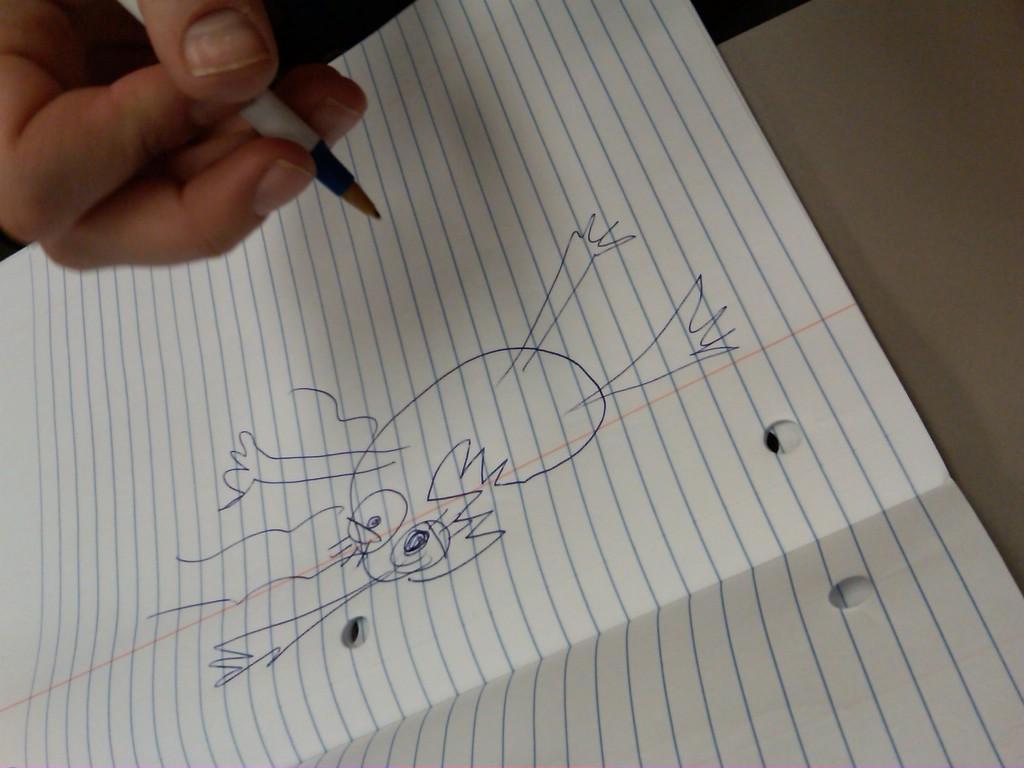Please provide a concise description of this image. In this image we can see some person holding the pen and we can also see the paper with the drawing. 